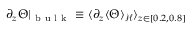<formula> <loc_0><loc_0><loc_500><loc_500>\partial _ { z } \Theta | _ { b u l k } \equiv \langle \partial _ { z } \langle \Theta \rangle _ { \mathcal { H } } \rangle _ { z \in [ 0 . 2 , 0 . 8 ] }</formula> 